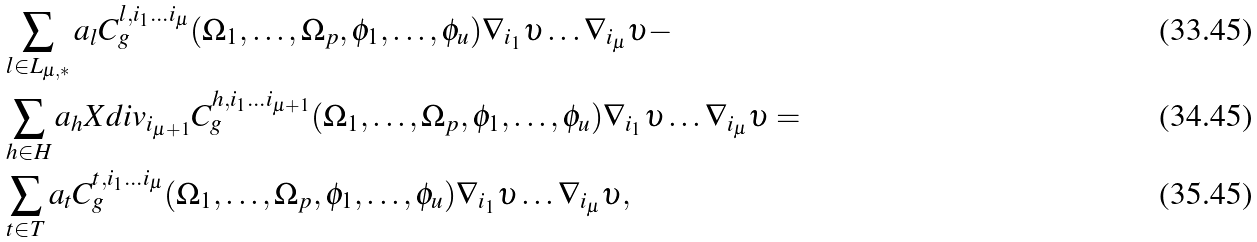Convert formula to latex. <formula><loc_0><loc_0><loc_500><loc_500>& \sum _ { l \in L _ { \mu , * } } a _ { l } C ^ { l , i _ { 1 } \dots i _ { \mu } } _ { g } ( \Omega _ { 1 } , \dots , \Omega _ { p } , \phi _ { 1 } , \dots , \phi _ { u } ) \nabla _ { i _ { 1 } } \upsilon \dots \nabla _ { i _ { \mu } } \upsilon - \\ & \sum _ { h \in H } a _ { h } X d i v _ { i _ { \mu + 1 } } C ^ { h , i _ { 1 } \dots i _ { \mu + 1 } } _ { g } ( \Omega _ { 1 } , \dots , \Omega _ { p } , \phi _ { 1 } , \dots , \phi _ { u } ) \nabla _ { i _ { 1 } } \upsilon \dots \nabla _ { i _ { \mu } } \upsilon = \\ & \sum _ { t \in T } a _ { t } C ^ { t , i _ { 1 } \dots i _ { \mu } } _ { g } ( \Omega _ { 1 } , \dots , \Omega _ { p } , \phi _ { 1 } , \dots , \phi _ { u } ) \nabla _ { i _ { 1 } } \upsilon \dots \nabla _ { i _ { \mu } } \upsilon ,</formula> 